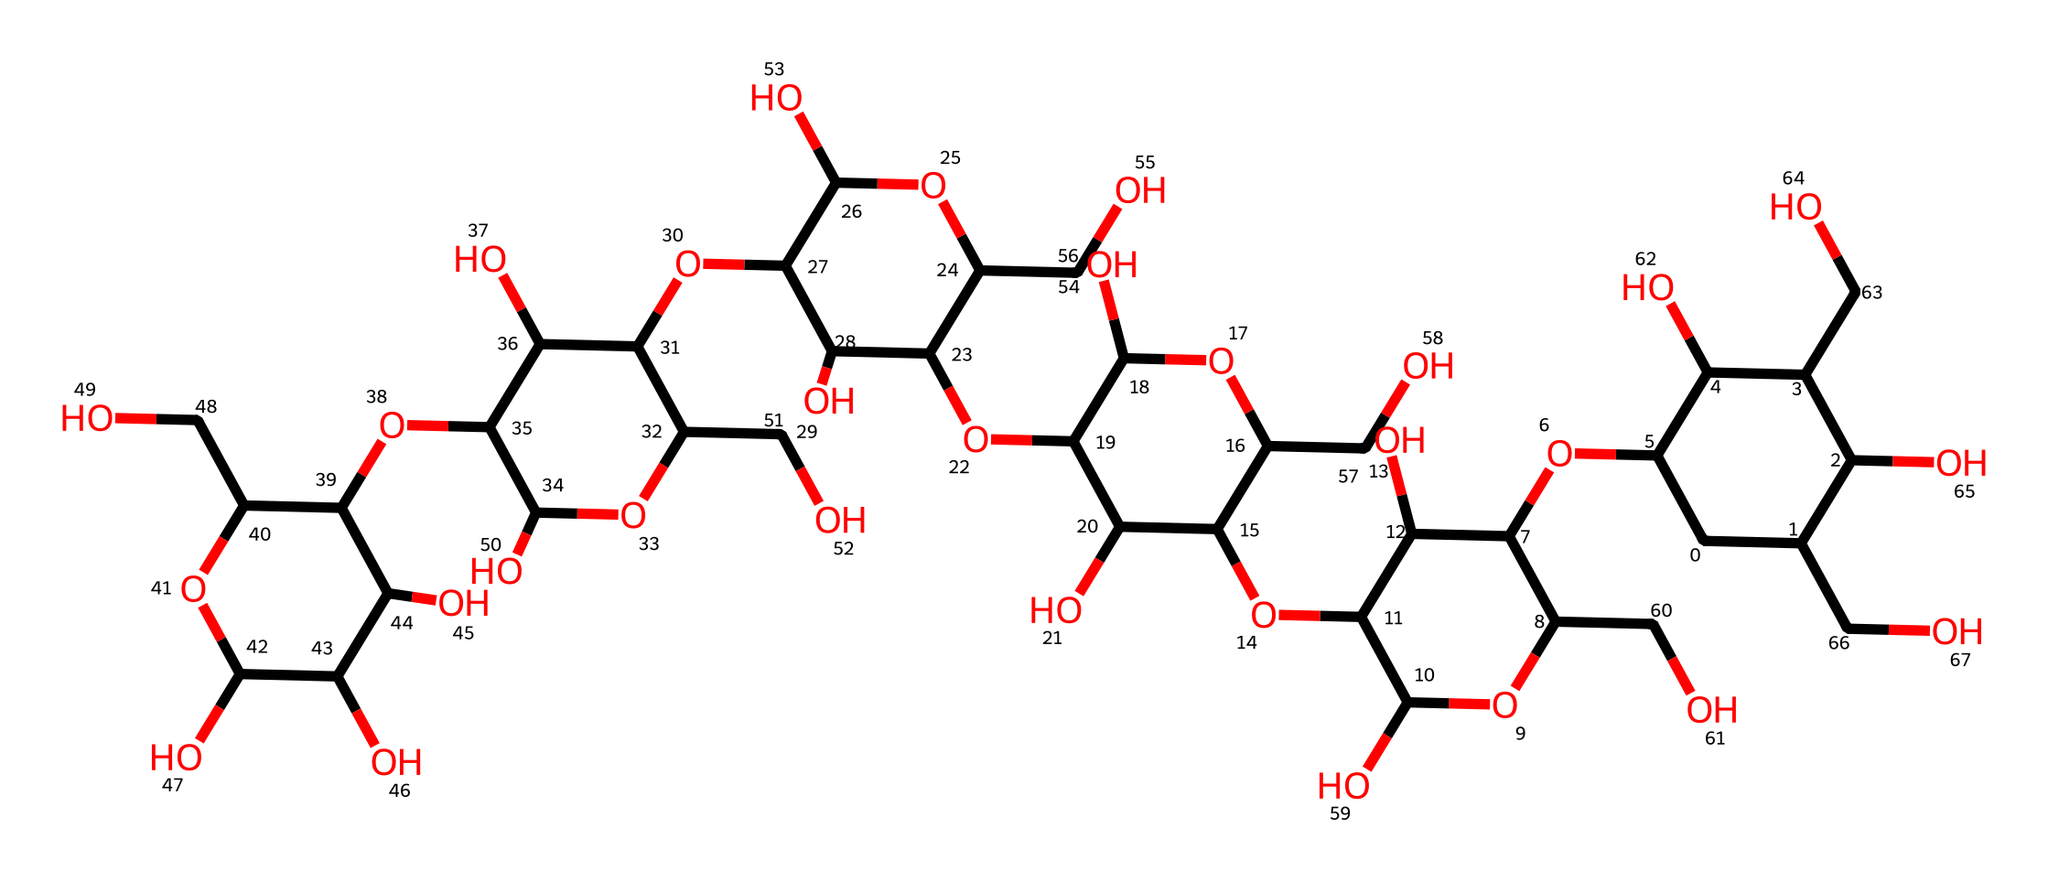What is the total number of carbon atoms in the structure? By analyzing the provided SMILES representation, we can count the 'C' characters representing carbon atoms. Each 'C' indicates a carbon atom, and by tallying them up in the structure, we arrive at a total count.
Answer: 30 How many oxygen atoms are present in this molecule? Similarly, we need to count the 'O' characters in the SMILES notation. Each 'O' denotes an oxygen atom. By adding them up, we find the total number of oxygen atoms in the compound.
Answer: 22 Is this compound a monosaccharide, disaccharide, or polysaccharide? Observing the structure, we can see multiple rings and an extensive structure of connected sugar units, indicative of a polysaccharide, as it is composed of multiple sugar units (specifically, glucopyranose).
Answer: polysaccharide What functional groups are present in this carbohydrate? By examining the structure, we can identify hydroxyl (-OH) groups attached to the carbon atoms, which are characteristic of carbohydrates. The presence of these functional groups indicates the molecule's solubility in water.
Answer: hydroxyl groups What is the significance of cyclodextrins in air fresheners? Cyclodextrins are particularly useful due to their ability to encapsulate odors and volatile substances, which helps in controlling fragrances within a confined space like a recording studio, making the environment more pleasant.
Answer: odor encapsulation How many rings does this molecule contain? The structure reveals several cyclic components due to the 'C' character followed by numerical identifiers, indicating multiple ring structures present in the molecule. Counting these instances leads to the identification of the distinct rings.
Answer: 6 